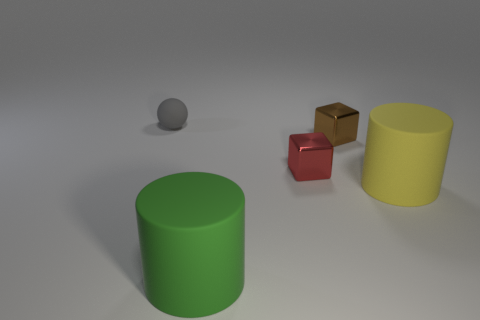What is the color of the large cylinder that is on the right side of the green object?
Provide a short and direct response. Yellow. Do the red metal object and the large rubber thing on the left side of the brown object have the same shape?
Provide a short and direct response. No. Are there any metal cylinders that have the same color as the tiny matte ball?
Keep it short and to the point. No. There is a green cylinder that is the same material as the tiny gray thing; what size is it?
Ensure brevity in your answer.  Large. Does the tiny object in front of the small brown metallic cube have the same shape as the large green rubber object?
Keep it short and to the point. No. What number of green shiny balls have the same size as the red metallic thing?
Your answer should be compact. 0. Is there a red shiny object to the right of the cylinder right of the green cylinder?
Keep it short and to the point. No. What number of things are either small things that are on the left side of the small red object or gray spheres?
Provide a short and direct response. 1. How many brown shiny cubes are there?
Ensure brevity in your answer.  1. There is a small red object that is the same material as the small brown block; what shape is it?
Your response must be concise. Cube. 